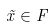<formula> <loc_0><loc_0><loc_500><loc_500>\tilde { x } \in F</formula> 